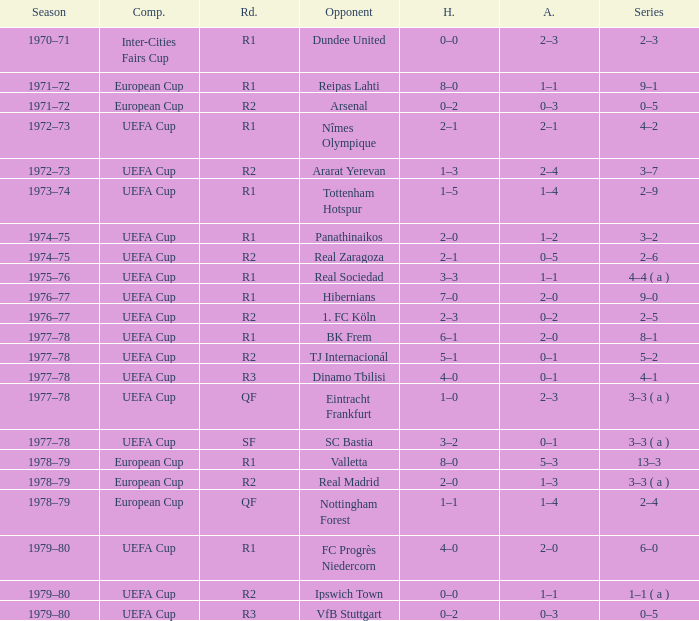Which Opponent has an Away of 1–1, and a Home of 3–3? Real Sociedad. 